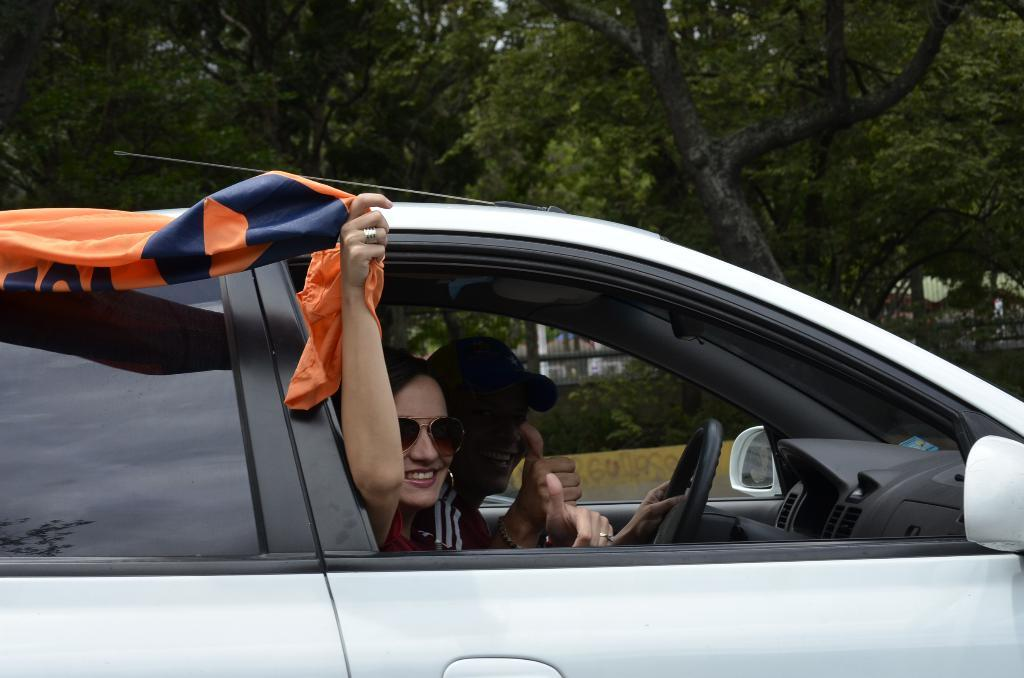What is happening in the image involving the car? There are two people sitting in a car. What is the woman holding in the image? The woman is holding a cloth. What can be seen in the background behind the vehicle? There are trees and a fence behind the vehicle. How many family members are present in the image? The provided facts do not mention any family members, so we cannot determine the number of family members present in the image. What type of support can be seen in the image? There is no mention of any support in the image, such as a cane or a wheelchair. 